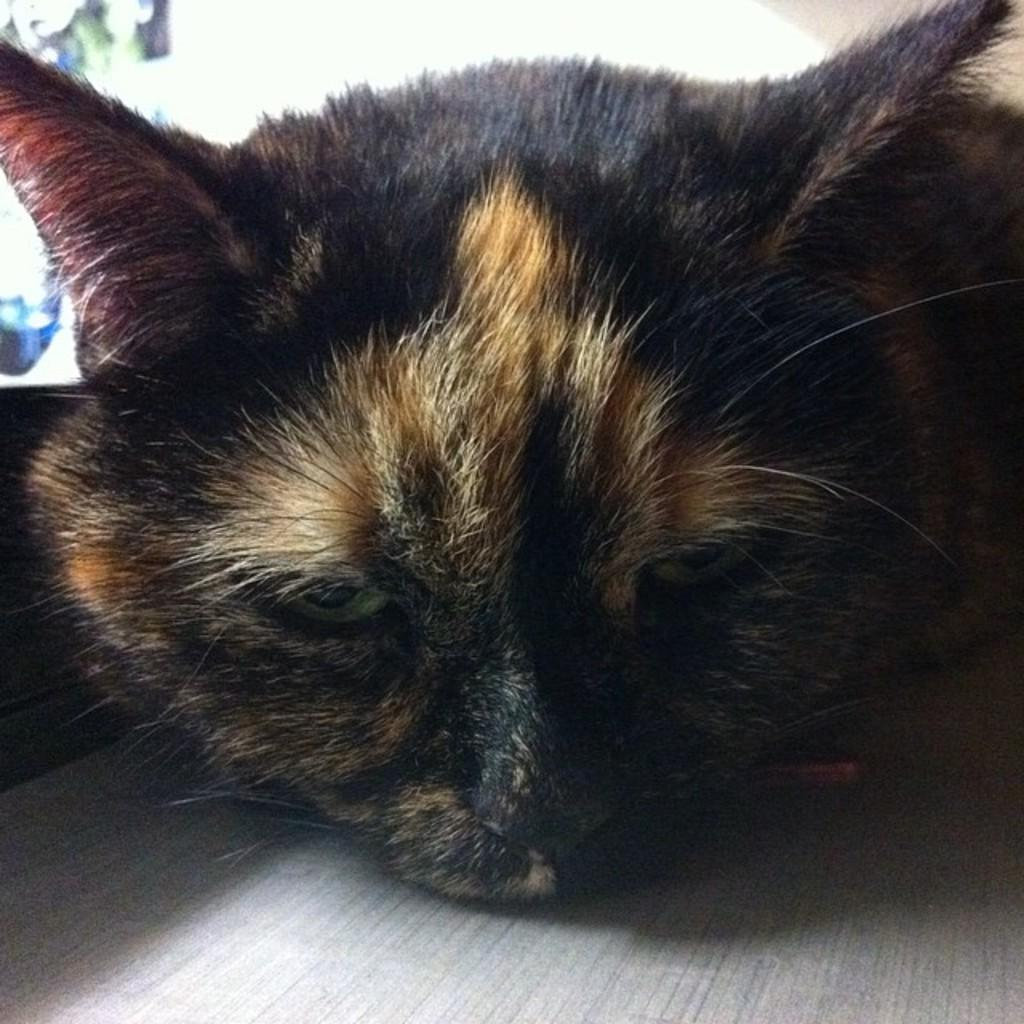What type of animal is in the image? There is a black color cat in the image. What can be seen in the background of the image? There is a wall in the background of the image. What type of chalk is the goat using to write good-bye messages in the image? There is no goat or chalk present in the image. The image only features a black color cat and a wall in the background. 